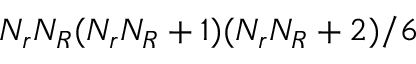Convert formula to latex. <formula><loc_0><loc_0><loc_500><loc_500>N _ { r } N _ { R } ( N _ { r } N _ { R } + 1 ) ( N _ { r } N _ { R } + 2 ) / 6</formula> 